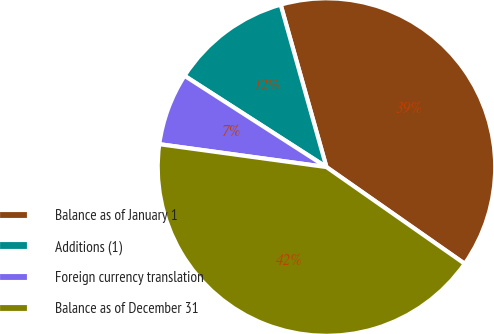Convert chart to OTSL. <chart><loc_0><loc_0><loc_500><loc_500><pie_chart><fcel>Balance as of January 1<fcel>Additions (1)<fcel>Foreign currency translation<fcel>Balance as of December 31<nl><fcel>39.09%<fcel>11.53%<fcel>6.93%<fcel>42.45%<nl></chart> 